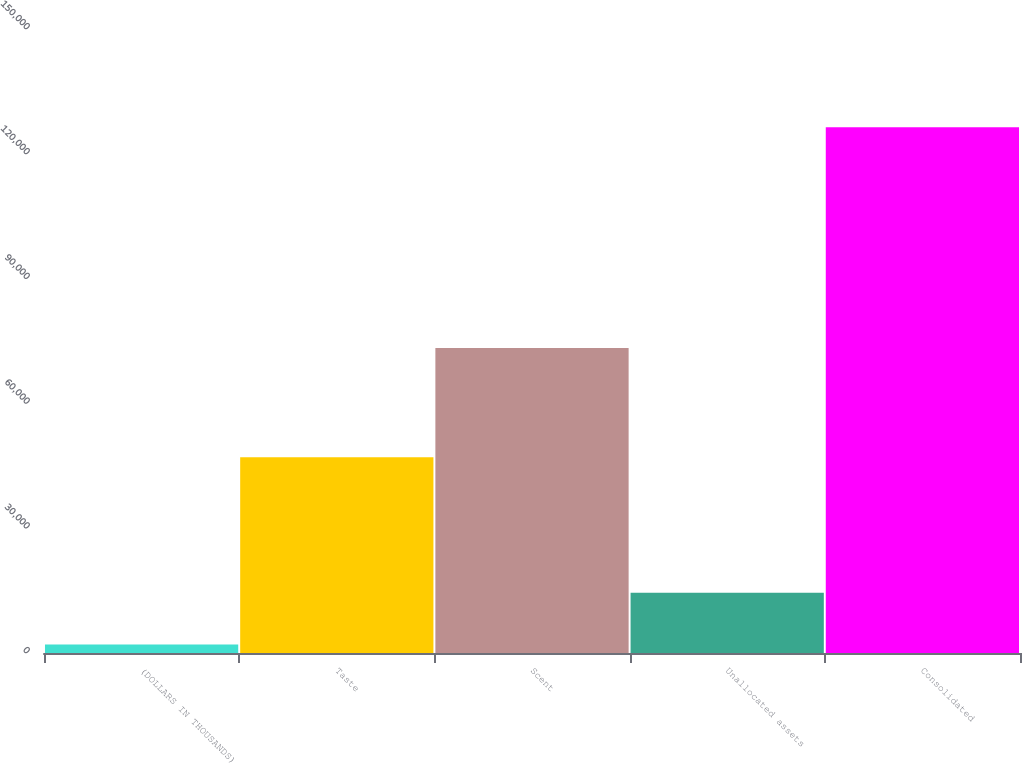Convert chart. <chart><loc_0><loc_0><loc_500><loc_500><bar_chart><fcel>(DOLLARS IN THOUSANDS)<fcel>Taste<fcel>Scent<fcel>Unallocated assets<fcel>Consolidated<nl><fcel>2016<fcel>47064<fcel>73345<fcel>14455.6<fcel>126412<nl></chart> 